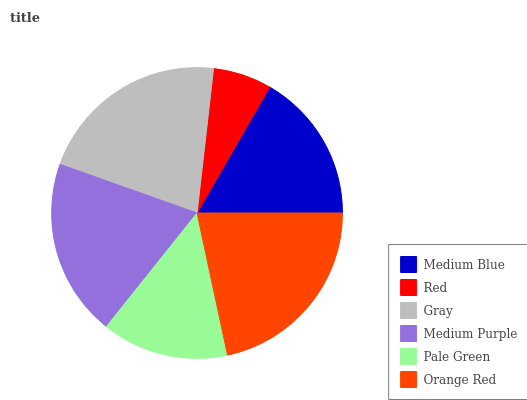Is Red the minimum?
Answer yes or no. Yes. Is Orange Red the maximum?
Answer yes or no. Yes. Is Gray the minimum?
Answer yes or no. No. Is Gray the maximum?
Answer yes or no. No. Is Gray greater than Red?
Answer yes or no. Yes. Is Red less than Gray?
Answer yes or no. Yes. Is Red greater than Gray?
Answer yes or no. No. Is Gray less than Red?
Answer yes or no. No. Is Medium Purple the high median?
Answer yes or no. Yes. Is Medium Blue the low median?
Answer yes or no. Yes. Is Red the high median?
Answer yes or no. No. Is Medium Purple the low median?
Answer yes or no. No. 